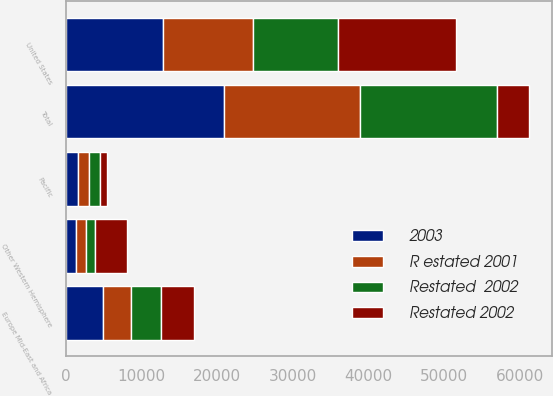Convert chart. <chart><loc_0><loc_0><loc_500><loc_500><stacked_bar_chart><ecel><fcel>United States<fcel>Europe Mid-East and Africa<fcel>Other Western Hemisphere<fcel>Pacific<fcel>Total<nl><fcel>2003<fcel>12897<fcel>4985<fcel>1333<fcel>1679<fcel>20894<nl><fcel>Restated  2002<fcel>11348<fcel>4041<fcel>1215<fcel>1502<fcel>18106<nl><fcel>R estated 2001<fcel>11802<fcel>3606<fcel>1289<fcel>1347<fcel>18044<nl><fcel>Restated 2002<fcel>15560<fcel>4313<fcel>4204<fcel>945<fcel>4204<nl></chart> 